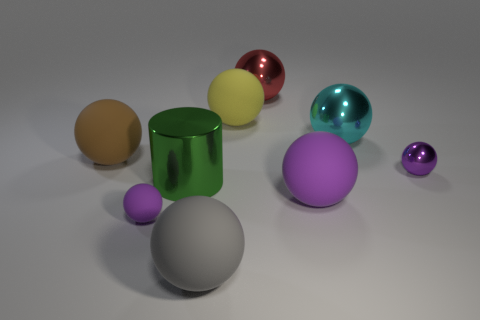There is a thing that is left of the gray ball and on the right side of the small purple rubber ball; what is its shape?
Ensure brevity in your answer.  Cylinder. Are there any large matte spheres that have the same color as the tiny shiny thing?
Your response must be concise. Yes. Are any large matte cylinders visible?
Your answer should be very brief. No. What is the color of the metallic ball left of the cyan shiny ball?
Make the answer very short. Red. There is a purple metal sphere; is it the same size as the red shiny thing that is to the right of the gray ball?
Your answer should be compact. No. There is a metallic thing that is both left of the large cyan shiny ball and behind the tiny metal sphere; what size is it?
Ensure brevity in your answer.  Large. Is there a purple object made of the same material as the gray thing?
Make the answer very short. Yes. What is the shape of the large gray thing?
Give a very brief answer. Sphere. Is the brown matte sphere the same size as the purple shiny object?
Offer a very short reply. No. What number of other objects are the same shape as the big green metal thing?
Keep it short and to the point. 0. 